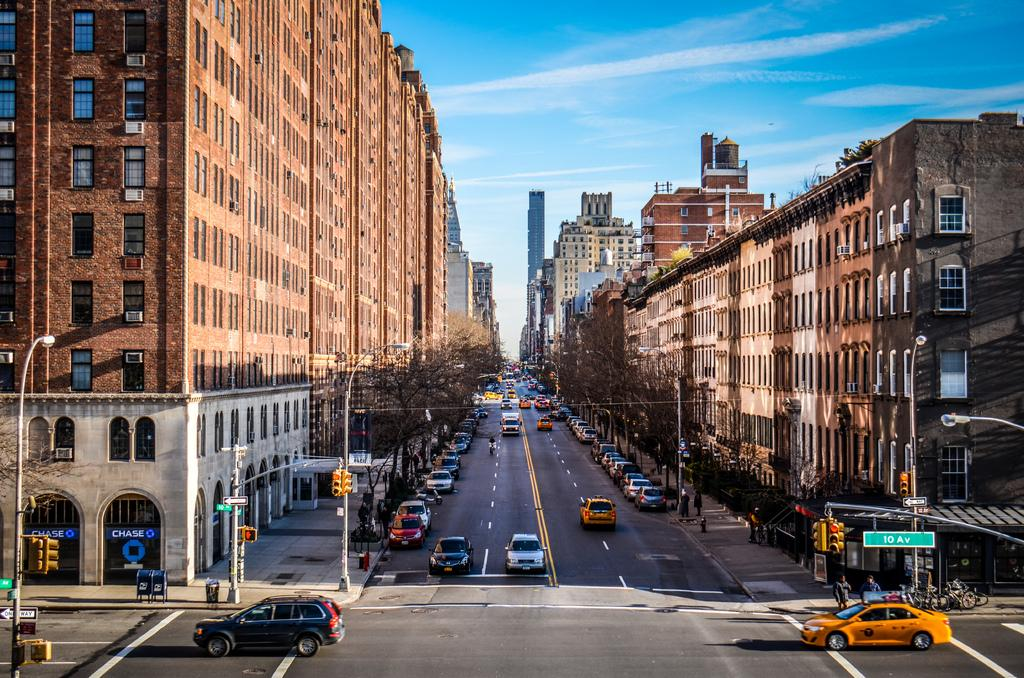<image>
Offer a succinct explanation of the picture presented. A road with tall buildings and a blue sky with a street sign that says 10 AV. 